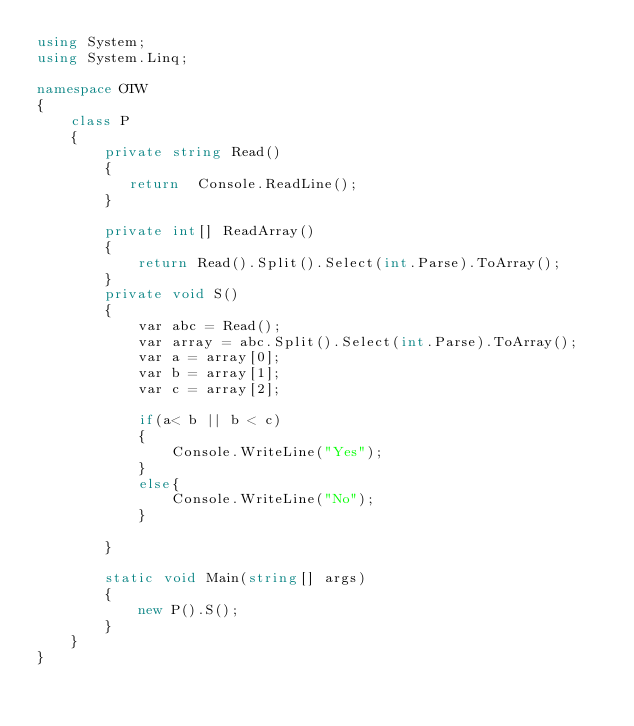Convert code to text. <code><loc_0><loc_0><loc_500><loc_500><_C#_>using System;
using System.Linq;

namespace OTW
{
    class P
    {
        private string Read()
        {
           return  Console.ReadLine();
        }

        private int[] ReadArray()
        {
            return Read().Split().Select(int.Parse).ToArray();
        }
        private void S()
        {
            var abc = Read();
            var array = abc.Split().Select(int.Parse).ToArray();
            var a = array[0];
            var b = array[1];
            var c = array[2];

            if(a< b || b < c)
            {
                Console.WriteLine("Yes");
            }
            else{
                Console.WriteLine("No");
            }

        }

        static void Main(string[] args)
        {
            new P().S();
        }
    }
}
</code> 